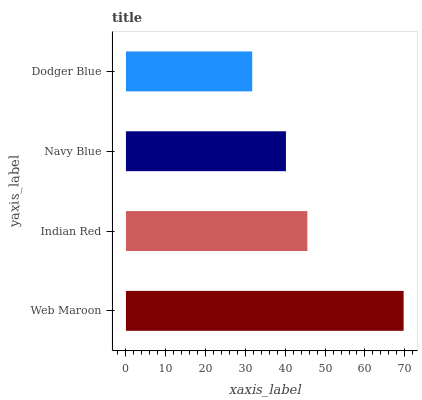Is Dodger Blue the minimum?
Answer yes or no. Yes. Is Web Maroon the maximum?
Answer yes or no. Yes. Is Indian Red the minimum?
Answer yes or no. No. Is Indian Red the maximum?
Answer yes or no. No. Is Web Maroon greater than Indian Red?
Answer yes or no. Yes. Is Indian Red less than Web Maroon?
Answer yes or no. Yes. Is Indian Red greater than Web Maroon?
Answer yes or no. No. Is Web Maroon less than Indian Red?
Answer yes or no. No. Is Indian Red the high median?
Answer yes or no. Yes. Is Navy Blue the low median?
Answer yes or no. Yes. Is Navy Blue the high median?
Answer yes or no. No. Is Dodger Blue the low median?
Answer yes or no. No. 